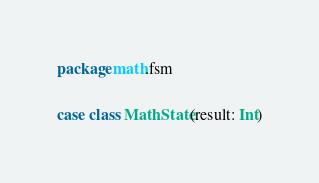Convert code to text. <code><loc_0><loc_0><loc_500><loc_500><_Scala_>package math.fsm

case class MathState(result: Int)
</code> 